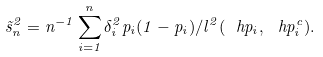<formula> <loc_0><loc_0><loc_500><loc_500>\tilde { s } _ { n } ^ { 2 } = n ^ { - 1 } \sum _ { i = 1 } ^ { n } \delta _ { i } ^ { 2 } p _ { i } ( 1 - p _ { i } ) / l ^ { 2 } ( \ h p _ { i } , \ h p _ { i } ^ { c } ) .</formula> 